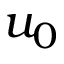Convert formula to latex. <formula><loc_0><loc_0><loc_500><loc_500>u _ { 0 }</formula> 